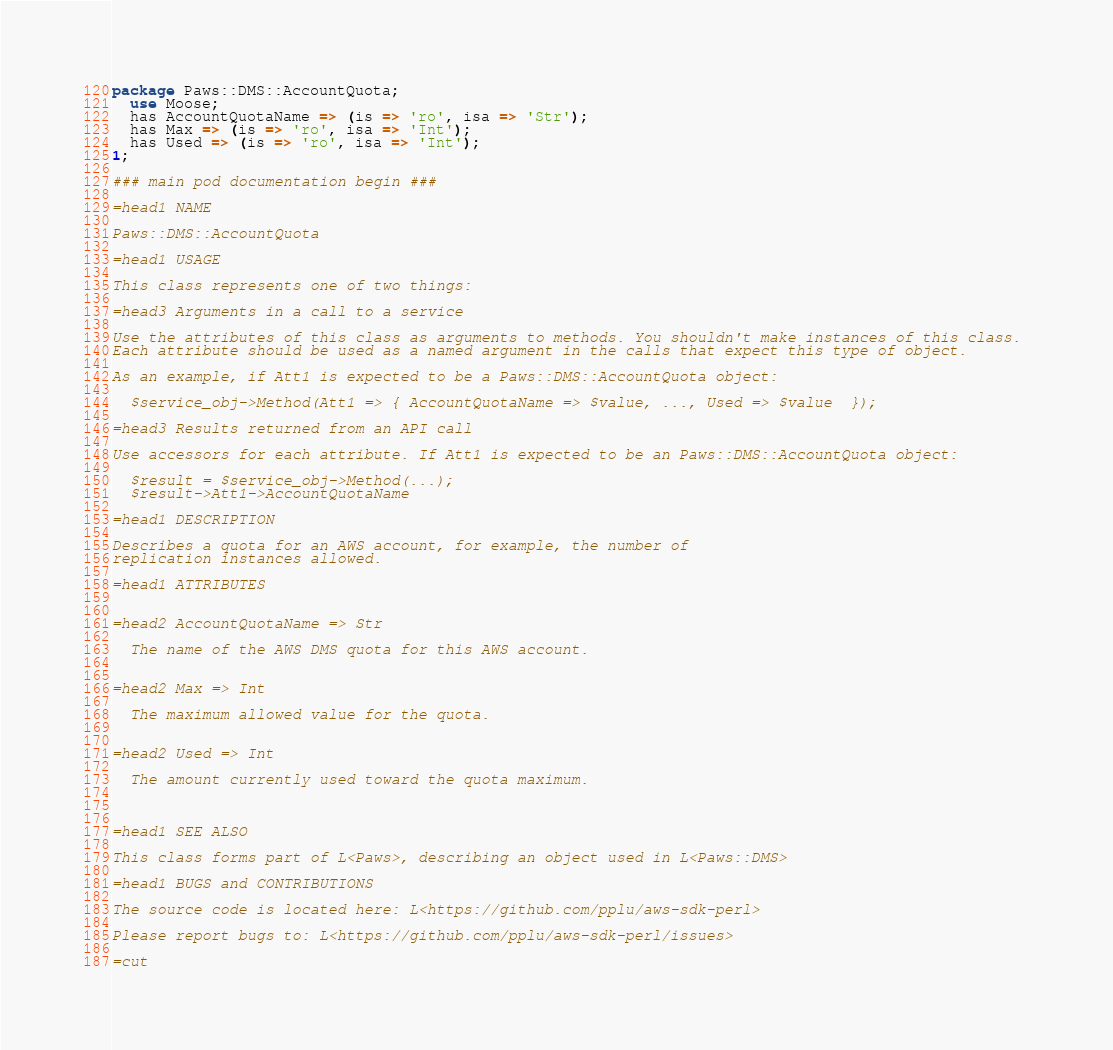Convert code to text. <code><loc_0><loc_0><loc_500><loc_500><_Perl_>package Paws::DMS::AccountQuota;
  use Moose;
  has AccountQuotaName => (is => 'ro', isa => 'Str');
  has Max => (is => 'ro', isa => 'Int');
  has Used => (is => 'ro', isa => 'Int');
1;

### main pod documentation begin ###

=head1 NAME

Paws::DMS::AccountQuota

=head1 USAGE

This class represents one of two things:

=head3 Arguments in a call to a service

Use the attributes of this class as arguments to methods. You shouldn't make instances of this class. 
Each attribute should be used as a named argument in the calls that expect this type of object.

As an example, if Att1 is expected to be a Paws::DMS::AccountQuota object:

  $service_obj->Method(Att1 => { AccountQuotaName => $value, ..., Used => $value  });

=head3 Results returned from an API call

Use accessors for each attribute. If Att1 is expected to be an Paws::DMS::AccountQuota object:

  $result = $service_obj->Method(...);
  $result->Att1->AccountQuotaName

=head1 DESCRIPTION

Describes a quota for an AWS account, for example, the number of
replication instances allowed.

=head1 ATTRIBUTES


=head2 AccountQuotaName => Str

  The name of the AWS DMS quota for this AWS account.


=head2 Max => Int

  The maximum allowed value for the quota.


=head2 Used => Int

  The amount currently used toward the quota maximum.



=head1 SEE ALSO

This class forms part of L<Paws>, describing an object used in L<Paws::DMS>

=head1 BUGS and CONTRIBUTIONS

The source code is located here: L<https://github.com/pplu/aws-sdk-perl>

Please report bugs to: L<https://github.com/pplu/aws-sdk-perl/issues>

=cut

</code> 